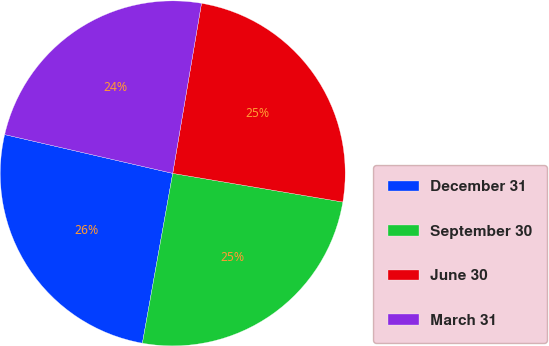Convert chart. <chart><loc_0><loc_0><loc_500><loc_500><pie_chart><fcel>December 31<fcel>September 30<fcel>June 30<fcel>March 31<nl><fcel>25.8%<fcel>25.16%<fcel>24.99%<fcel>24.06%<nl></chart> 